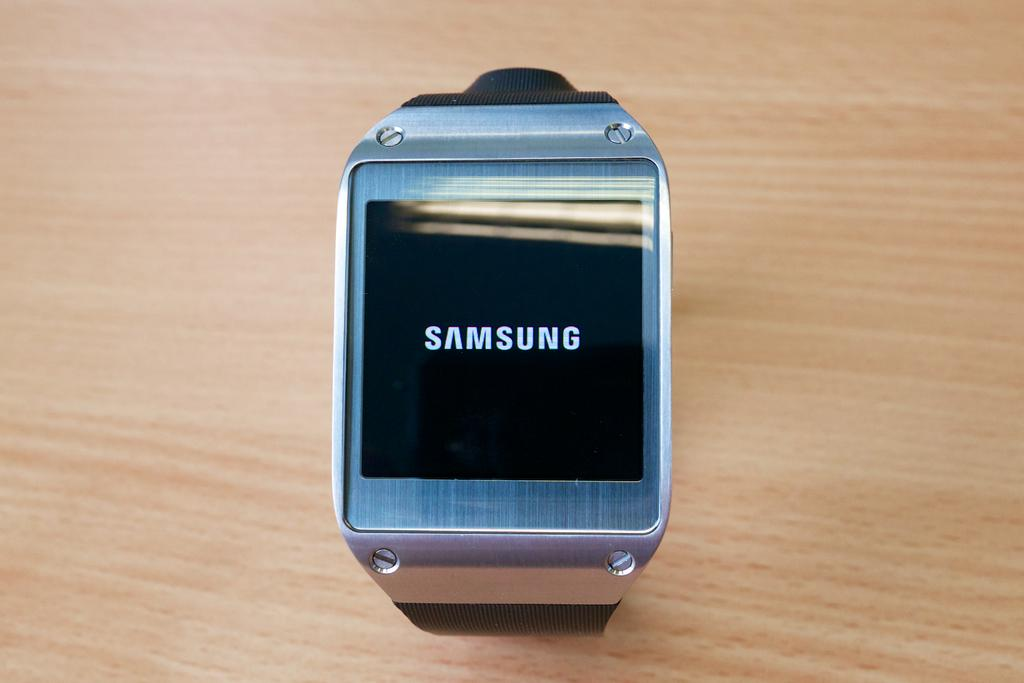Provide a one-sentence caption for the provided image. The silver Samsung watch has an LCD screen. 